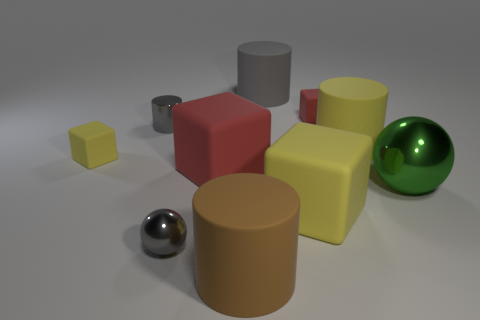What is the size of the shiny sphere that is the same color as the tiny cylinder?
Your answer should be very brief. Small. Are there any tiny yellow objects of the same shape as the big gray matte object?
Offer a very short reply. No. There is a tiny red matte object; does it have the same shape as the yellow rubber object left of the tiny gray shiny cylinder?
Your answer should be compact. Yes. What number of spheres are either yellow rubber things or gray shiny objects?
Your answer should be very brief. 1. The tiny metal object behind the big green thing has what shape?
Provide a short and direct response. Cylinder. How many large brown spheres are made of the same material as the large gray cylinder?
Your answer should be compact. 0. Are there fewer large green metal things behind the gray matte cylinder than small shiny cylinders?
Your answer should be very brief. Yes. How big is the shiny ball to the left of the yellow object that is in front of the large red matte block?
Ensure brevity in your answer.  Small. Do the tiny metal cylinder and the shiny thing in front of the green thing have the same color?
Offer a very short reply. Yes. What is the material of the gray sphere that is the same size as the shiny cylinder?
Make the answer very short. Metal. 